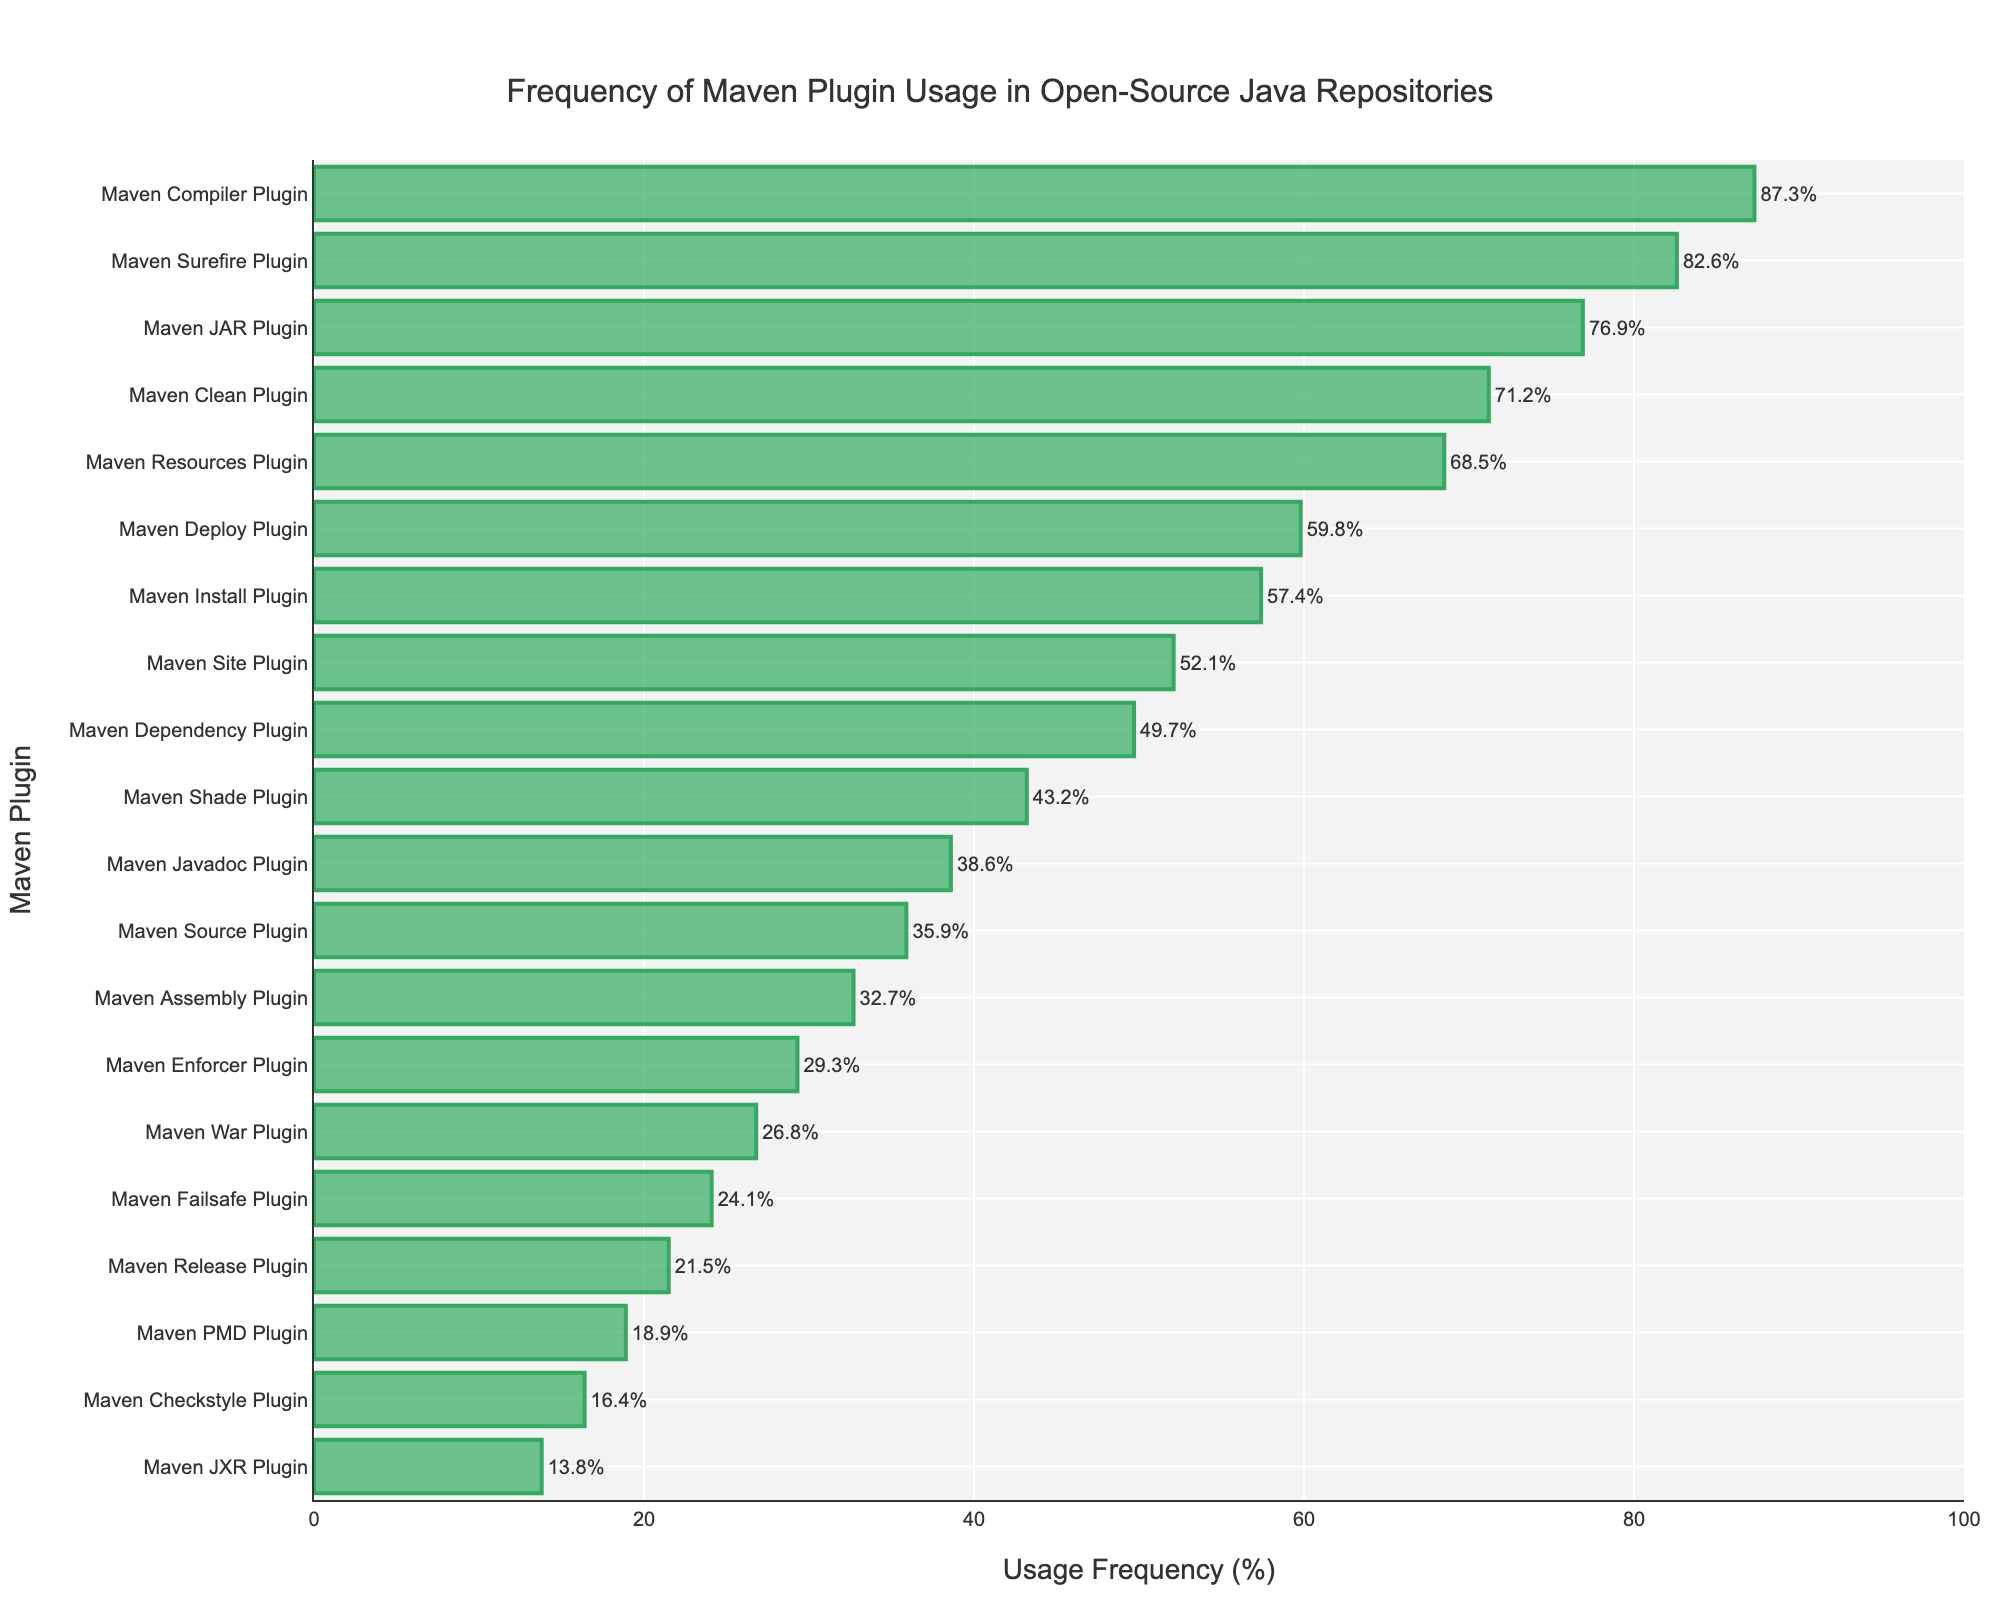What is the most frequently used Maven plugin? The most frequently used Maven plugin is the one with the highest value on the x-axis. From the figure, the 'Maven Compiler Plugin' has the highest usage frequency at 87.3%.
Answer: Maven Compiler Plugin Which plugin has the lowest usage frequency? The plugin with the lowest usage frequency will be at the bottom of the y-axis. From the figure, the 'Maven JXR Plugin' has the lowest usage frequency at 13.8%.
Answer: Maven JXR Plugin How does the usage frequency of the Maven Surefire Plugin compare to that of the Maven Failsafe Plugin? To compare the usage frequencies, observe the x-axis values for both plugins. The 'Maven Surefire Plugin' has a usage frequency of 82.6%, while the 'Maven Failsafe Plugin' has a usage frequency of 24.1%. Hence, the 'Maven Surefire Plugin' is used more frequently.
Answer: Maven Surefire Plugin is used more frequently What is the approximate difference in usage frequency between the Maven Clean Plugin and the Maven Install Plugin? To find the difference, subtract the usage frequency of the Maven Install Plugin (57.4%) from that of the Maven Clean Plugin (71.2%). The calculation is 71.2% - 57.4% = 13.8%.
Answer: 13.8% Which plugins have a usage frequency greater than 50%? Plugins with a usage frequency greater than 50% will have bars extending past the 50% mark on the x-axis. From the figure, these plugins are: Maven Compiler Plugin, Maven Surefire Plugin, Maven JAR Plugin, Maven Clean Plugin, Maven Resources Plugin, Maven Deploy Plugin, Maven Install Plugin, and Maven Site Plugin.
Answer: Maven Compiler Plugin, Maven Surefire Plugin, Maven JAR Plugin, Maven Clean Plugin, Maven Resources Plugin, Maven Deploy Plugin, Maven Install Plugin, Maven Site Plugin What is the median usage frequency of all listed Maven plugins? To find the median, first sort the usage frequencies in ascending order and then locate the middle value. The usage frequencies in ascending order are: 13.8, 16.4, 18.9, 21.5, 24.1, 26.8, 29.3, 32.7, 35.9, 38.6, 43.2, 49.7, 52.1, 57.4, 59.8, 68.5, 71.2, 76.9, 82.6, 87.3. The median value is the average of the 10th and 11th values: (38.6 + 43.2) / 2 = 40.9%.
Answer: 40.9% Which plugin has a usage frequency closest to the average usage frequency? First, calculate the average usage frequency by summing all the percentages and dividing by the number of plugins. The sum of all usage frequencies is 851.7%. There are 20 plugins, so the average is 851.7 / 20 = 42.6%. The plugin closest to this average is the 'Maven Shade Plugin' with a frequency of 43.2%.
Answer: Maven Shade Plugin 